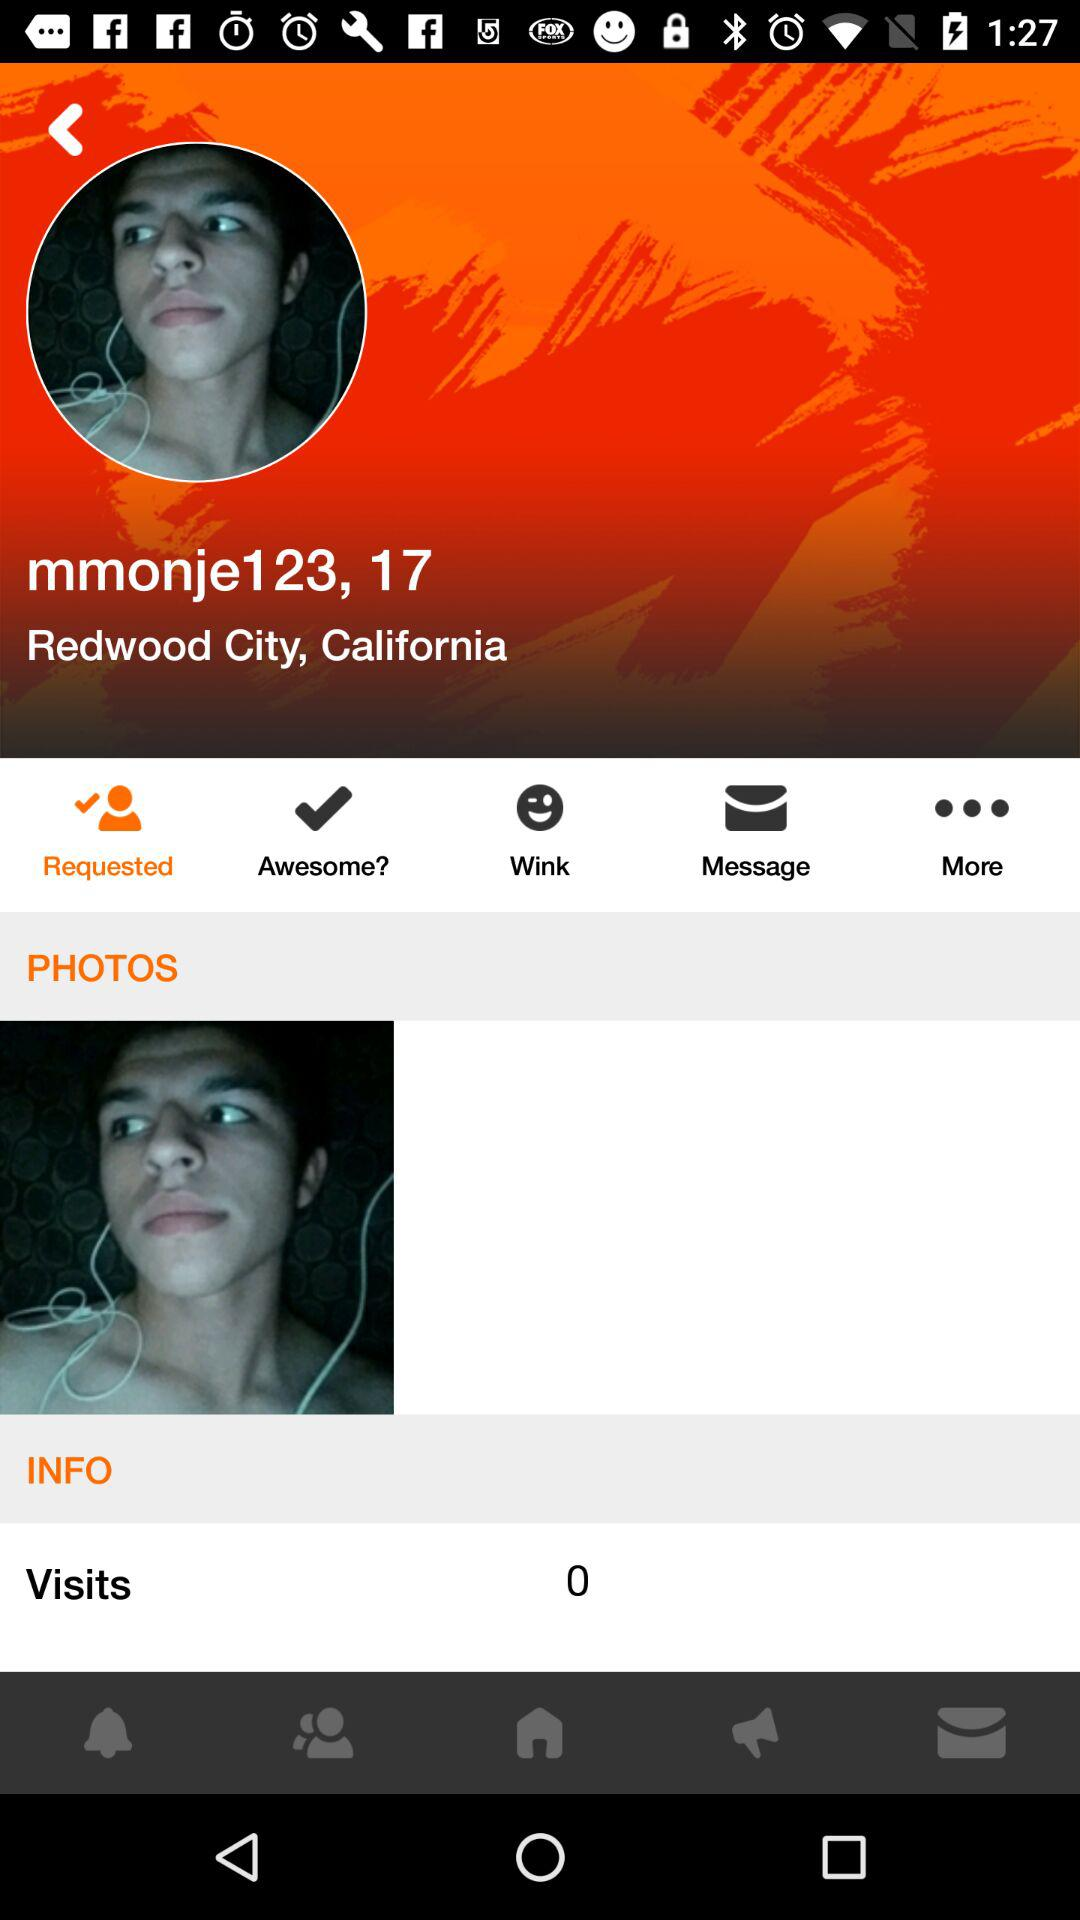What is the status of request?
When the provided information is insufficient, respond with <no answer>. <no answer> 